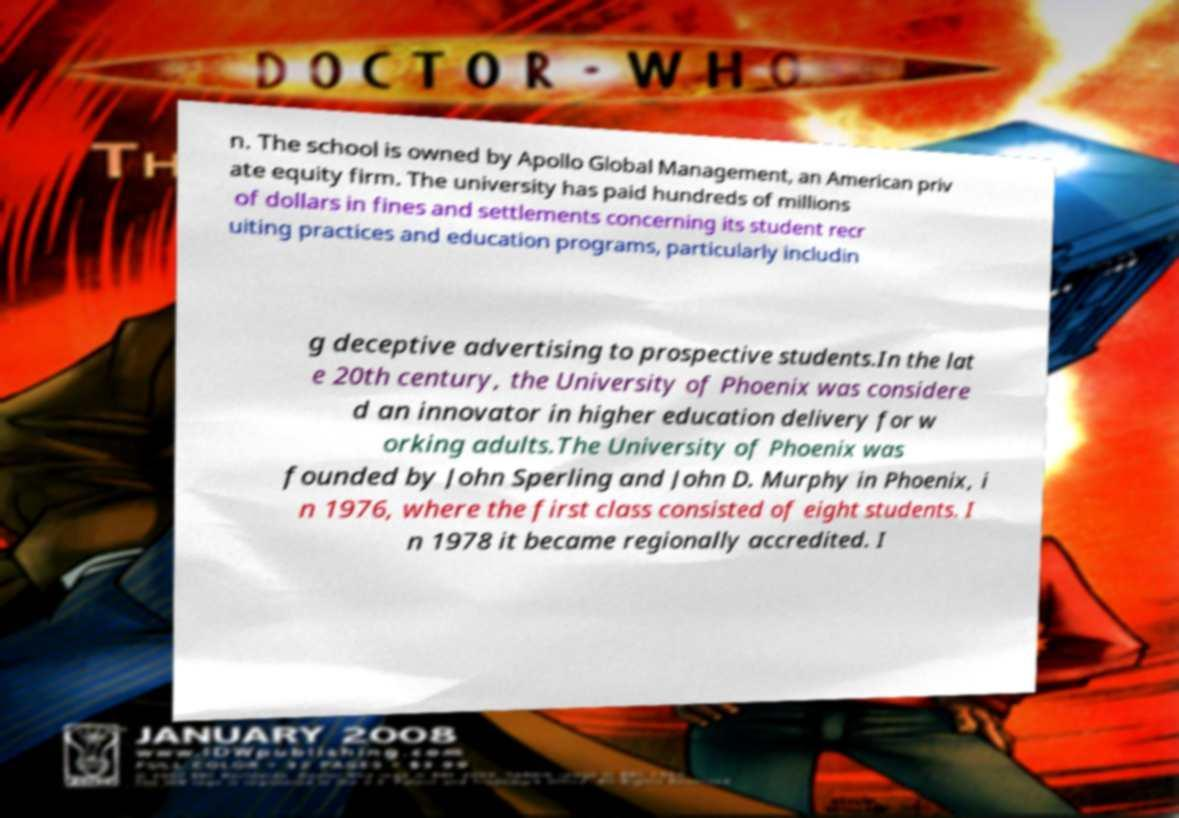Can you read and provide the text displayed in the image?This photo seems to have some interesting text. Can you extract and type it out for me? n. The school is owned by Apollo Global Management, an American priv ate equity firm. The university has paid hundreds of millions of dollars in fines and settlements concerning its student recr uiting practices and education programs, particularly includin g deceptive advertising to prospective students.In the lat e 20th century, the University of Phoenix was considere d an innovator in higher education delivery for w orking adults.The University of Phoenix was founded by John Sperling and John D. Murphy in Phoenix, i n 1976, where the first class consisted of eight students. I n 1978 it became regionally accredited. I 